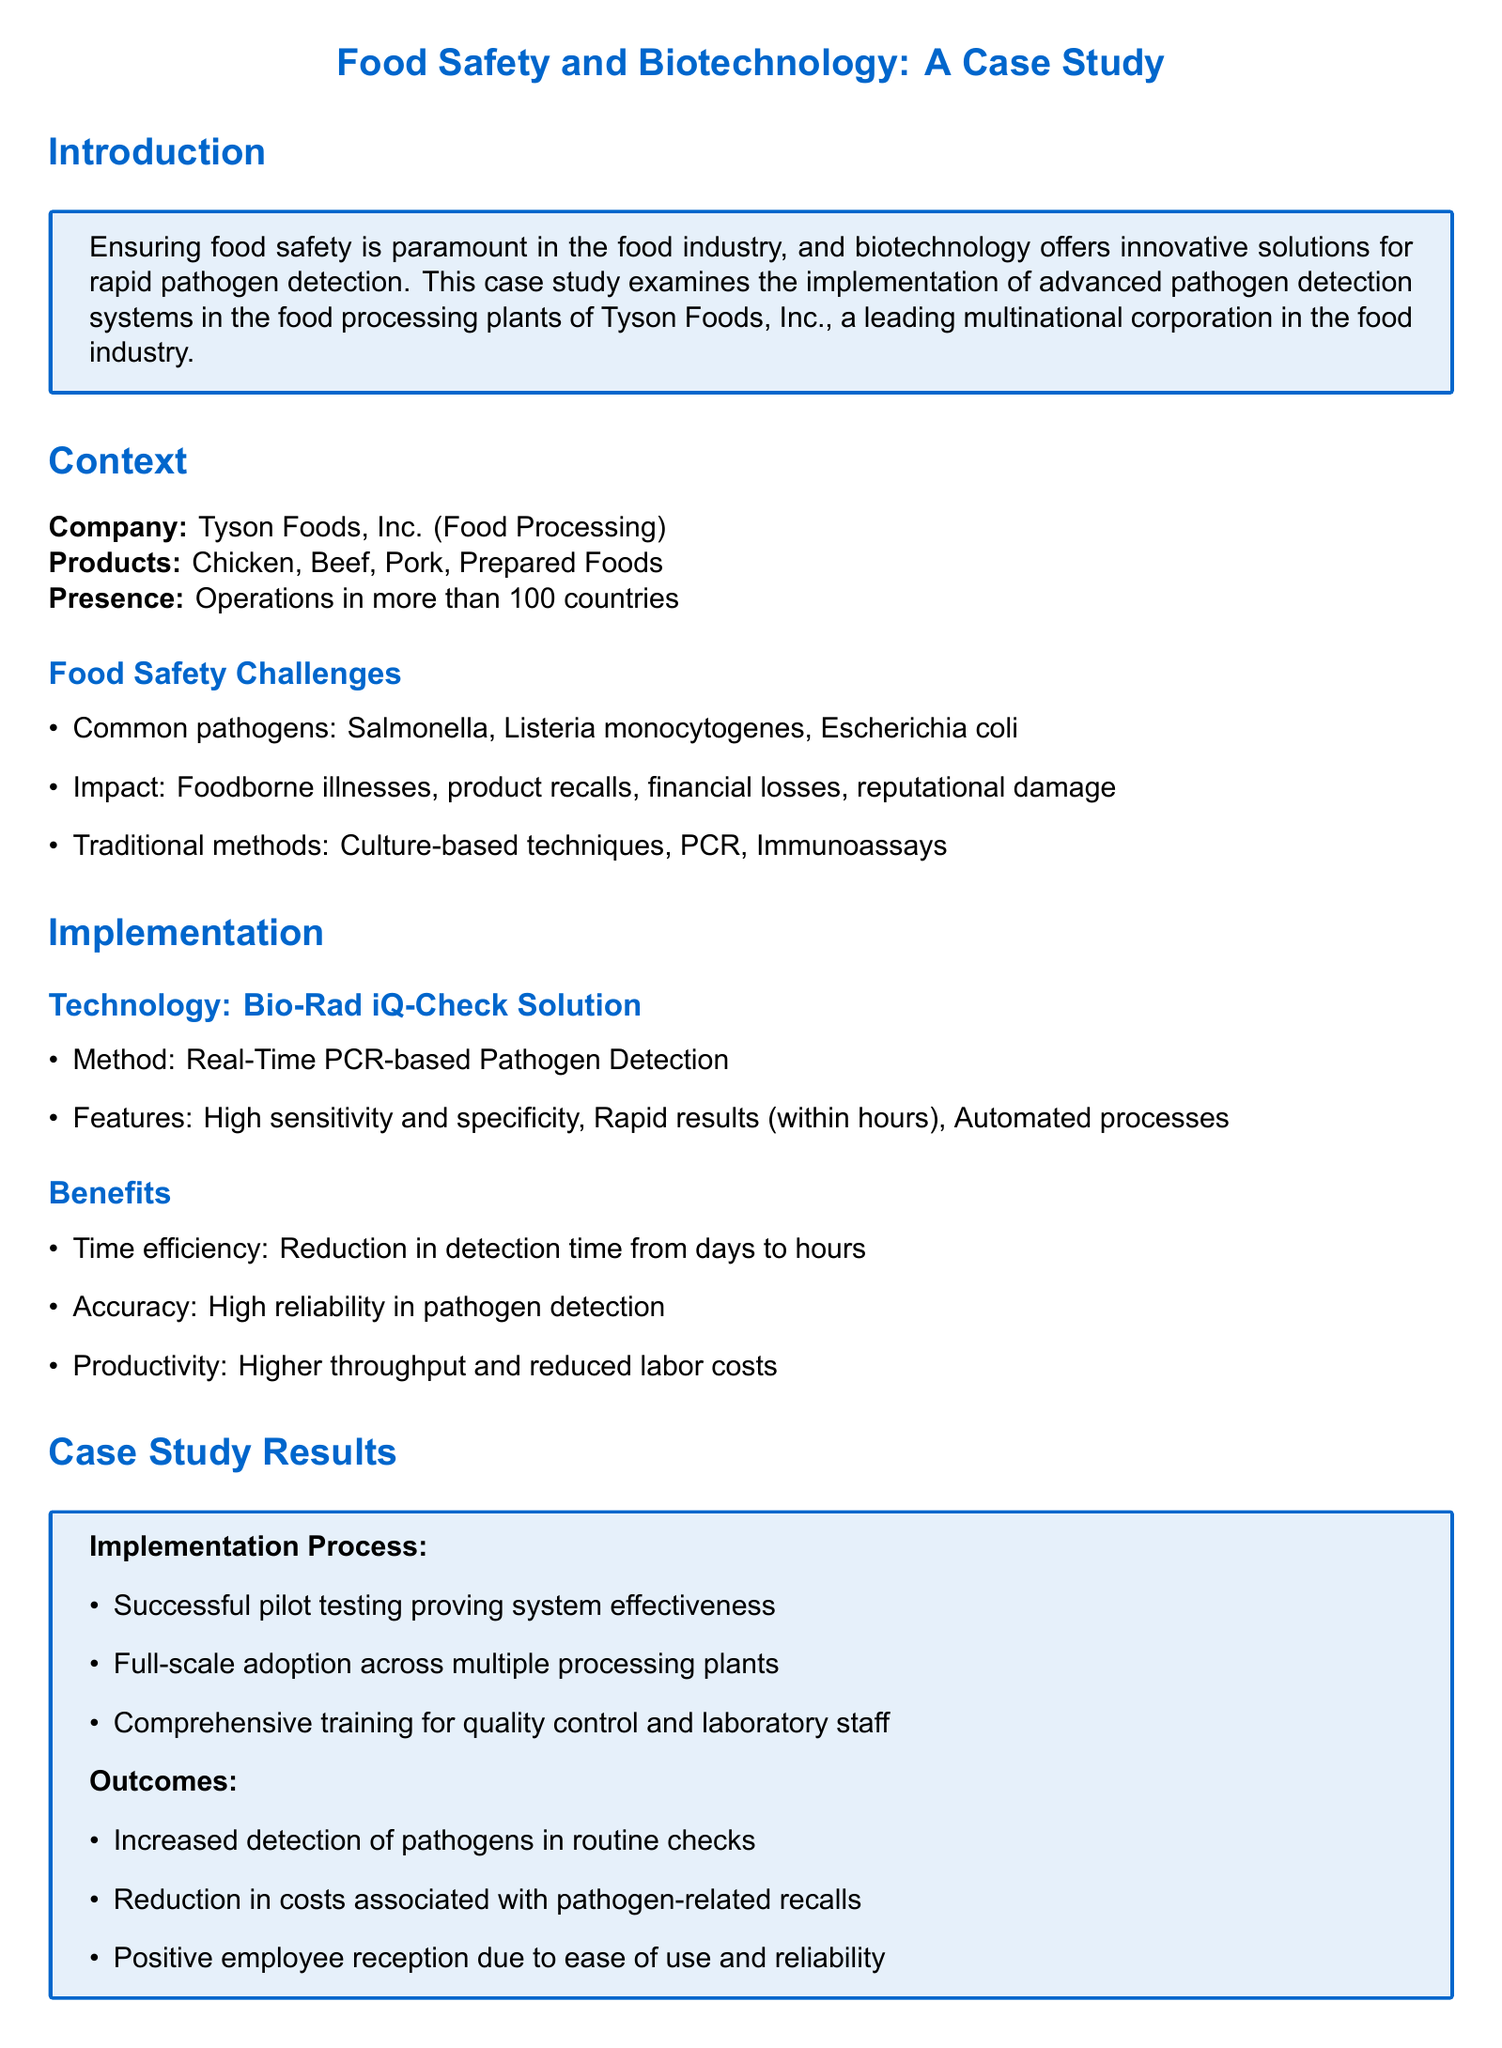What is the name of the company in the case study? The company mentioned in the case study is Tyson Foods, Inc.
Answer: Tyson Foods, Inc What pathogens are commonly found in the food safety challenges? The document lists three common pathogens: Salmonella, Listeria monocytogenes, and Escherichia coli.
Answer: Salmonella, Listeria monocytogenes, Escherichia coli What technology is implemented for pathogen detection? The technology used for rapid pathogen detection is the Bio-Rad iQ-Check Solution.
Answer: Bio-Rad iQ-Check Solution What is the time reduction in pathogen detection? The implementation of this technology reduces detection time from days to hours.
Answer: Days to hours What type of PCR is utilized in the pathogen detection method? The pathogen detection method mentioned in the document employs Real-Time PCR.
Answer: Real-Time PCR How many countries does Tyson Foods operate in? The document states that Tyson Foods has operations in more than 100 countries.
Answer: More than 100 countries What is one of the benefits of using the Bio-Rad iQ-Check Solution? One significant benefit mentioned is time efficiency.
Answer: Time efficiency What was one outcome of the full-scale adoption of the solution? An outcome noted was an increased detection of pathogens in routine checks.
Answer: Increased detection of pathogens What did employees think about the new technology? The positive reception from employees is highlighted, and they appreciated its ease of use and reliability.
Answer: Positive employee reception 